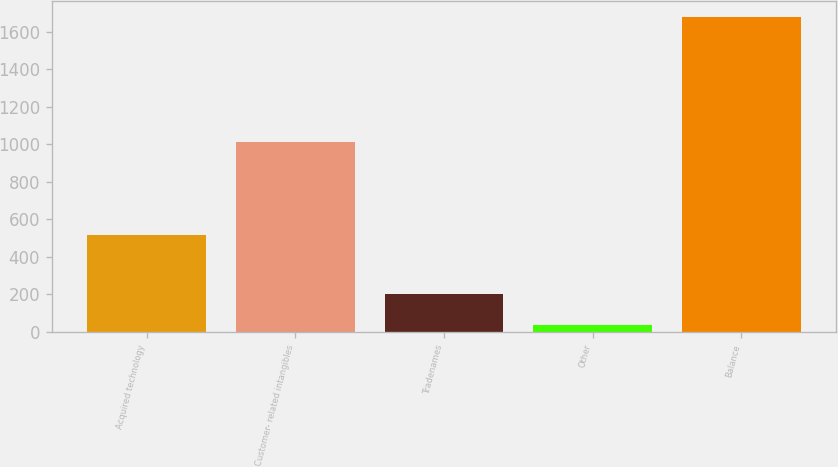Convert chart. <chart><loc_0><loc_0><loc_500><loc_500><bar_chart><fcel>Acquired technology<fcel>Customer- related intangibles<fcel>Tradenames<fcel>Other<fcel>Balance<nl><fcel>516<fcel>1010<fcel>198.6<fcel>34<fcel>1680<nl></chart> 